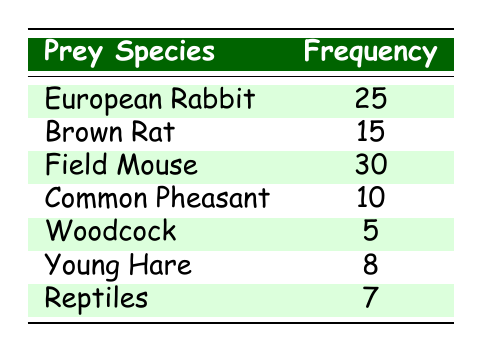What is the frequency of the European Rabbit captured by vixens? The table shows the specific frequency for each prey species. The frequency of the European Rabbit is listed directly in the table as 25.
Answer: 25 What is the least frequently captured prey species? By examining the frequency values in the table, the Woodcock has the lowest frequency at 5.
Answer: Woodcock How many more Field Mice are captured than Young Hares? The frequency of Field Mice is 30 and Young Hares is 8. The difference is calculated as 30 - 8 = 22.
Answer: 22 What is the total frequency of all prey species captured by vixens? To find the total frequency, we add up the frequencies of all the prey species: 25 + 15 + 30 + 10 + 5 + 8 + 7 = 100.
Answer: 100 Is the frequency of Reptiles greater than 10? The frequency of Reptiles is listed as 7. Since 7 is less than 10, the statement is false.
Answer: No Which prey species has a frequency greater than 20? From the table, the species with a frequency greater than 20 are the European Rabbit (25) and Field Mouse (30).
Answer: European Rabbit and Field Mouse How many more prey species have a frequency less than 10 compared to those with a frequency more than 20? There are two species with a frequency less than 10 (Woodcock and Reptiles) and two species with a frequency greater than 20 (European Rabbit and Field Mouse). Therefore, the difference is 2 - 2 = 0.
Answer: 0 What is the average frequency of all the prey species captured? To find the average, we first calculate the total frequency (100) and then divide by the number of species (7). So the average is 100 / 7 = approximately 14.29.
Answer: Approximately 14.29 Who is the most frequently captured prey species, and how many were captured? From the data, the Field Mouse has the highest frequency of 30, so it is the most frequently captured.
Answer: Field Mouse, 30 